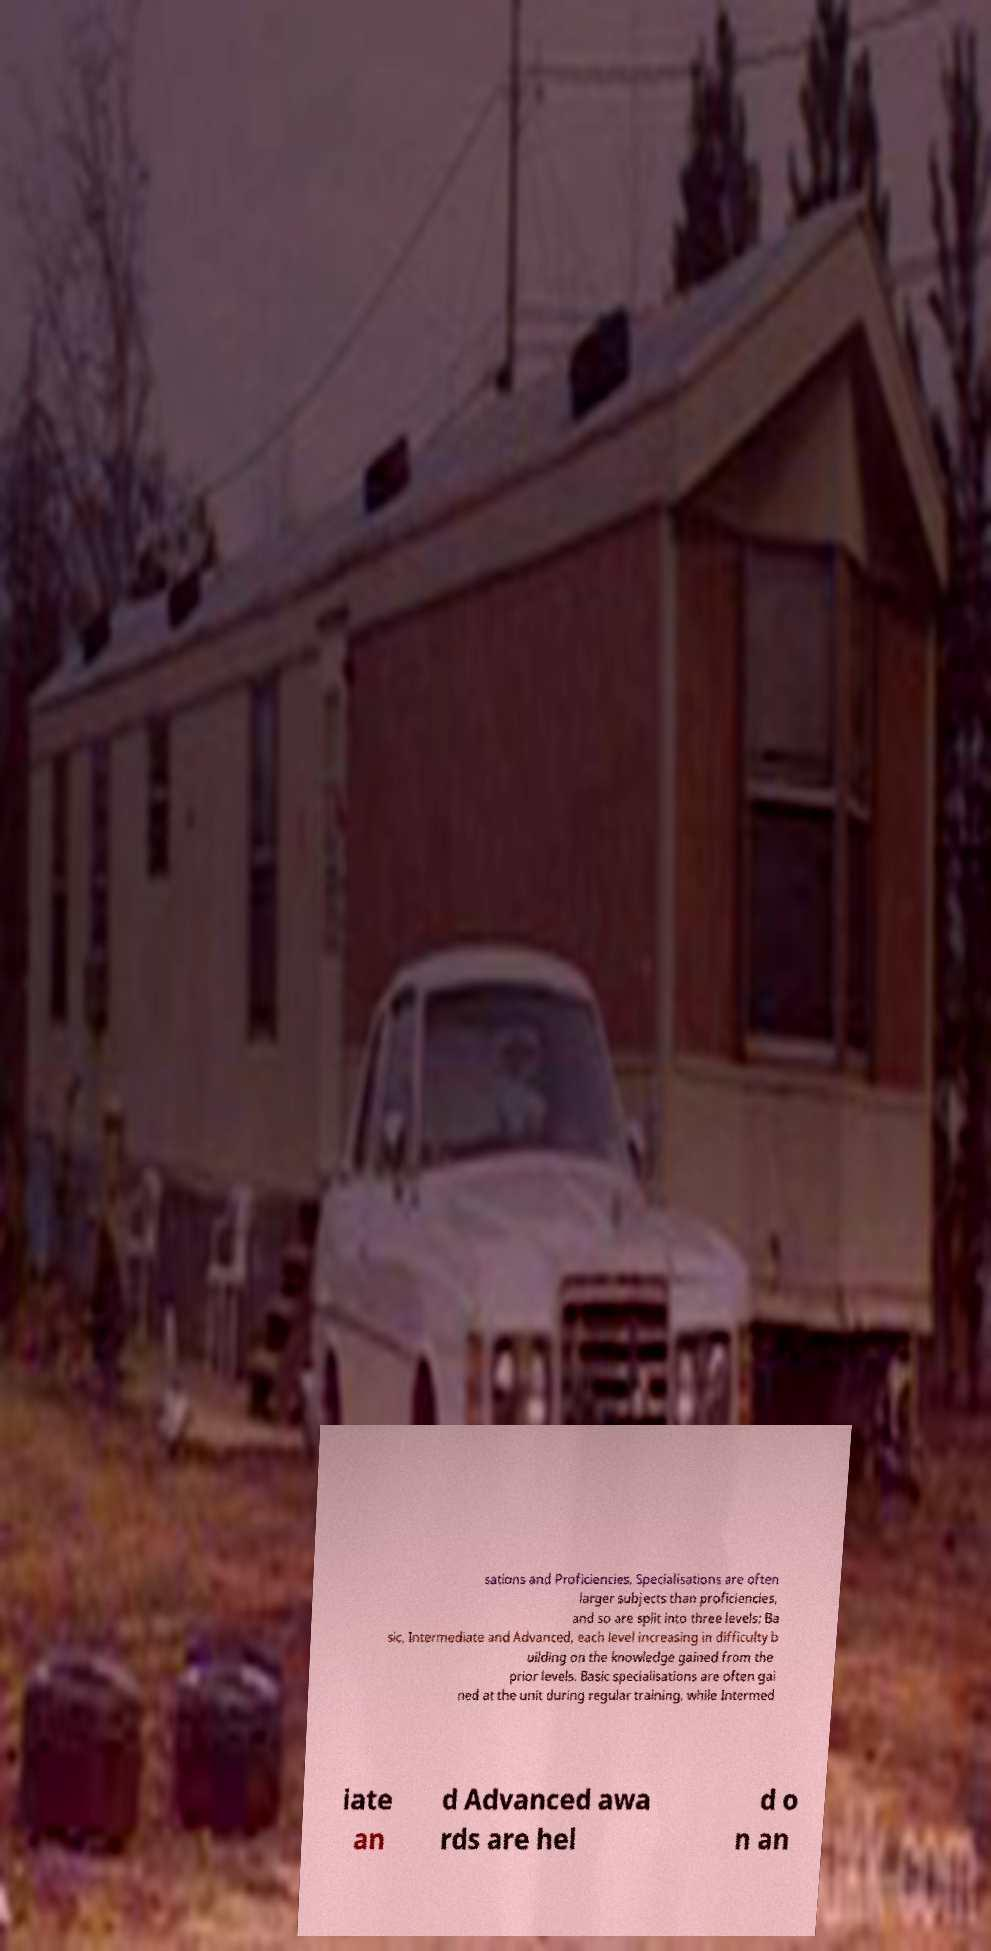Can you accurately transcribe the text from the provided image for me? sations and Proficiencies. Specialisations are often larger subjects than proficiencies, and so are split into three levels; Ba sic, Intermediate and Advanced, each level increasing in difficulty b uilding on the knowledge gained from the prior levels. Basic specialisations are often gai ned at the unit during regular training, while Intermed iate an d Advanced awa rds are hel d o n an 